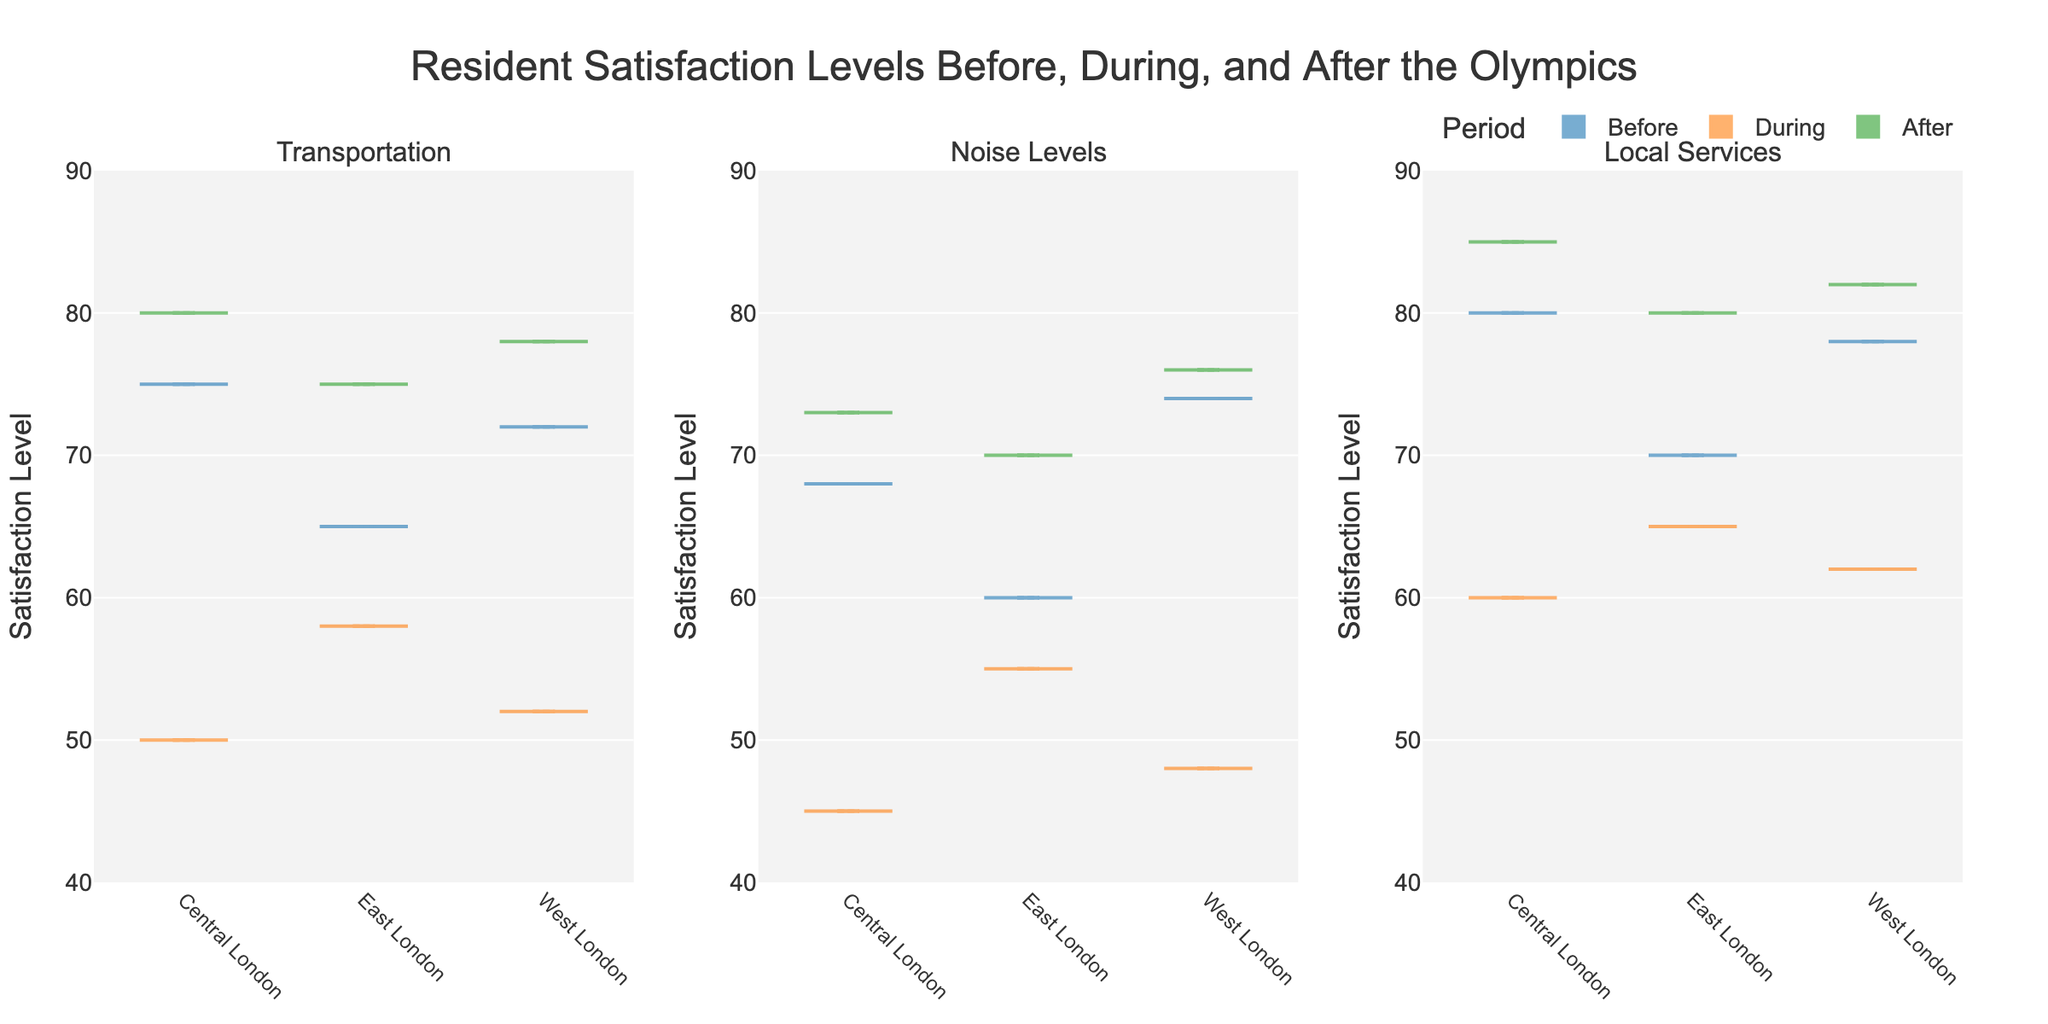How many violin plots are there in total? There are three subplots, each containing three violin plots (one for each period: Before, During, After). Multiplying 3 subplots by 3 violin plots gives a total of 9 violin plots in the figure.
Answer: 9 What is the title of the figure? The title of the figure is displayed at the top of the plot and reads "Resident Satisfaction Levels Before, During, and After the Olympics".
Answer: Resident Satisfaction Levels Before, During, and After the Olympics Which location had the highest satisfaction for Transportation during the period "After"? The "After" violin plots for Transportation show data for Central London, East London, and West London. Looking at the y-axes, West London has the highest satisfaction level at 78.
Answer: West London Did the satisfaction levels for Noise Levels increase or decrease in Central London during the Olympics compared to before the Olympics? Comparing the "Before" and "During" violin plots for Noise Levels in Central London, the median dropped from 68 to 45. This indicates a decrease in satisfaction.
Answer: Decrease How does the median satisfaction level for Local Services in East London change from "Before" to "After" the Olympics? The "Before" violin plot for Local Services in East London shows a median around 70. The "After" plot shows a median at 80. This indicates an increase in median satisfaction.
Answer: Increase What period has the lowest overall satisfaction for Noise Levels in East London? The violin plot for Noise Levels in East London shows that the "During" period has the lowest median satisfaction level at around 55.
Answer: During Compare the median satisfaction levels of Transportation in Central London during the periods "Before" and "During". What can be observed? The median satisfaction for Transportation in Central London drops significantly from 75 "Before" to 50 "During". This indicates a decrease in satisfaction levels.
Answer: Decrease Which aspect, Transportation, Noise Levels, or Local Services, shows the greatest improvement in satisfaction levels in West London from "Before" to "After"? By comparing the medians of each aspect in West London, Transportation increased from 72 to 78, Noise Levels from 74 to 76, and Local Services from 78 to 82. The greatest increase is in Local Services, which increased by 4 points.
Answer: Local Services What is the range of satisfaction levels for Noise Levels in East London "During" the Olympics? The range can be observed from the extent of the violin plot for East London during the "During" period for Noise Levels. The values appear to range from approximately 50 to 55.
Answer: 50-55 In which period did East London residents have the highest satisfaction with Local Services, and what was the satisfaction level? The violin plot for East London for Local Services shows that the highest median satisfaction level, which is 80, occurred in the "After" period.
Answer: After, 80 